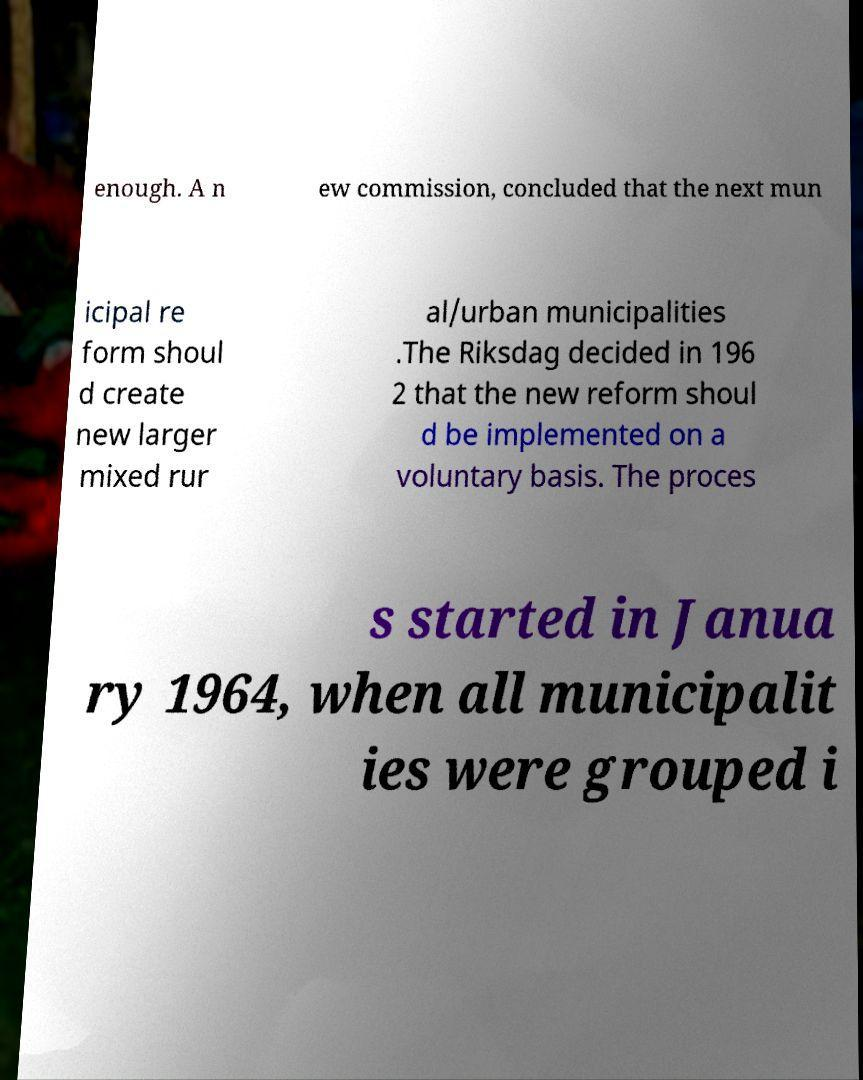Can you accurately transcribe the text from the provided image for me? enough. A n ew commission, concluded that the next mun icipal re form shoul d create new larger mixed rur al/urban municipalities .The Riksdag decided in 196 2 that the new reform shoul d be implemented on a voluntary basis. The proces s started in Janua ry 1964, when all municipalit ies were grouped i 